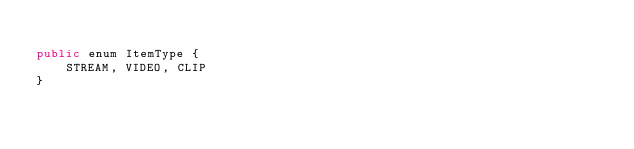Convert code to text. <code><loc_0><loc_0><loc_500><loc_500><_Java_>
public enum ItemType {
    STREAM, VIDEO, CLIP
}
</code> 